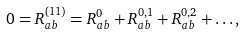Convert formula to latex. <formula><loc_0><loc_0><loc_500><loc_500>0 = R ^ { ( 1 1 ) } _ { a b } = R ^ { 0 } _ { a b } + R ^ { 0 , 1 } _ { a b } + R ^ { 0 , 2 } _ { a b } + \dots ,</formula> 